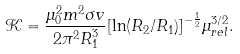<formula> <loc_0><loc_0><loc_500><loc_500>\mathcal { K } = \frac { { \mu } _ { 0 } ^ { 2 } m ^ { 2 } \sigma v } { 2 { \pi } ^ { 2 } { R } _ { 1 } ^ { 3 } } { [ \ln ( R _ { 2 } / R _ { 1 } ) ] } ^ { - \frac { 1 } { 2 } } { \mu } _ { r e l } ^ { 3 / 2 } .</formula> 